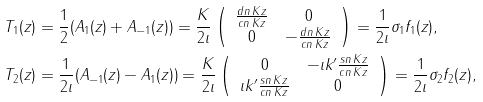Convert formula to latex. <formula><loc_0><loc_0><loc_500><loc_500>T _ { 1 } ( z ) & = \frac { 1 } { 2 } ( A _ { 1 } ( z ) + A _ { - 1 } ( z ) ) = \frac { K } { 2 \imath } \left ( \begin{array} { c c } \frac { d n \, K z } { c n \, K z } & 0 \\ 0 & - \frac { d n \, K z } { c n \, K z } \end{array} \right ) = \frac { 1 } { 2 \imath } \sigma _ { 1 } f _ { 1 } ( z ) , \\ T _ { 2 } ( z ) & = \frac { 1 } { 2 \imath } ( A _ { - 1 } ( z ) - A _ { 1 } ( z ) ) = \frac { K } { 2 \imath } \left ( \begin{array} { c c } 0 & - \imath k ^ { \prime } \frac { s n \, K z } { c n \, K z } \\ \imath k ^ { \prime } \frac { s n \, K z } { c n \, K z } & 0 \end{array} \right ) = \frac { 1 } { 2 \imath } \sigma _ { 2 } f _ { 2 } ( z ) ,</formula> 